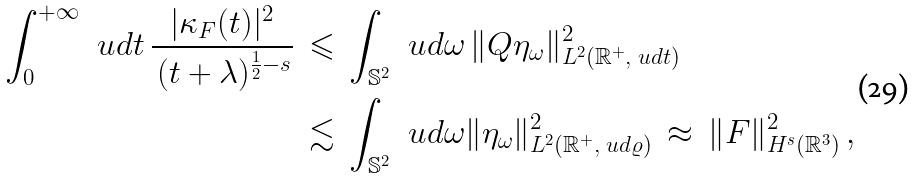Convert formula to latex. <formula><loc_0><loc_0><loc_500><loc_500>\int _ { 0 } ^ { + \infty } \, \ u d t \, \frac { | \kappa _ { F } ( t ) | ^ { 2 } } { \, ( t + \lambda ) ^ { \frac { 1 } { 2 } - s } } \, & \leqslant \, \int _ { \mathbb { S } ^ { 2 } } \, \ u d \omega \, \| Q \eta _ { \omega } \| ^ { 2 } _ { L ^ { 2 } ( \mathbb { R } ^ { + } , \ u d t ) } \\ & \lesssim \, \int _ { \mathbb { S } ^ { 2 } } \, \ u d \omega \| \eta _ { \omega } \| ^ { 2 } _ { L ^ { 2 } ( \mathbb { R } ^ { + } , \ u d \varrho ) } \, \approx \, \| F \| ^ { 2 } _ { H ^ { s } ( \mathbb { R } ^ { 3 } ) } \, ,</formula> 